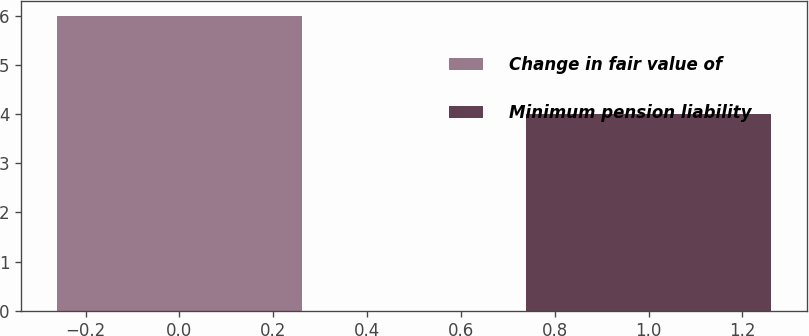Convert chart to OTSL. <chart><loc_0><loc_0><loc_500><loc_500><bar_chart><fcel>Change in fair value of<fcel>Minimum pension liability<nl><fcel>6<fcel>4<nl></chart> 